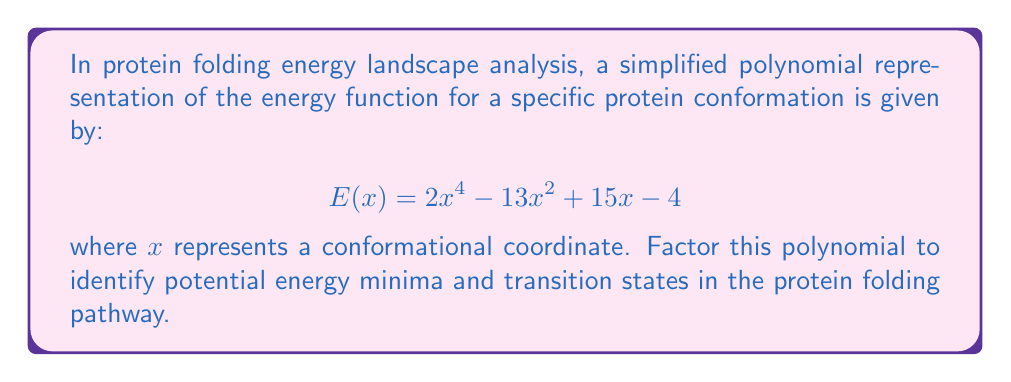Give your solution to this math problem. To factor this polynomial, we'll follow these steps:

1) First, we notice that this is not a perfect square trinomial, so we'll need to use the factor theorem or rational root theorem.

2) The possible rational roots are the factors of the constant term: ±1, ±2, ±4

3) Testing these values, we find that x = 1 is a root. So (x - 1) is a factor.

4) Divide the polynomial by (x - 1):

   $$\frac{2x^4 - 13x^2 + 15x - 4}{x - 1} = 2x^3 + 2x^2 - 11x + 11$$

5) Now we have: $E(x) = (x - 1)(2x^3 + 2x^2 - 11x + 11)$

6) The cubic factor can be further factored. Notice that x = -1 is a root of this cubic.

7) Dividing the cubic by (x + 1):

   $$\frac{2x^3 + 2x^2 - 11x + 11}{x + 1} = 2x^2 - 9$$

8) Therefore, $E(x) = (x - 1)(x + 1)(2x^2 - 9)$

9) The quadratic factor can be further factored:

   $2x^2 - 9 = 2(x^2 - \frac{9}{2}) = 2(x - \frac{3}{\sqrt{2}})(x + \frac{3}{\sqrt{2}})$

10) The final factored form is:

    $$E(x) = (x - 1)(x + 1)(2)(x - \frac{3}{\sqrt{2}})(x + \frac{3}{\sqrt{2}})$$

In protein folding terms, this factorization reveals that the energy landscape has potential minima or transition states at $x = 1, -1, \frac{3}{\sqrt{2}},$ and $-\frac{3}{\sqrt{2}}$.
Answer: $E(x) = 2(x - 1)(x + 1)(x - \frac{3}{\sqrt{2}})(x + \frac{3}{\sqrt{2}})$ 